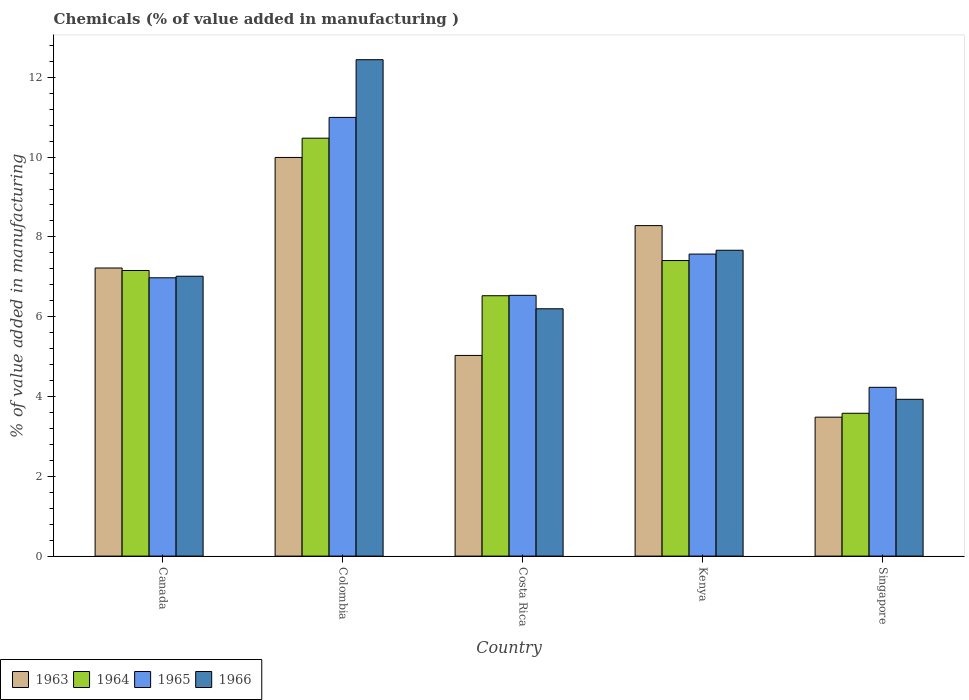Are the number of bars per tick equal to the number of legend labels?
Your answer should be compact. Yes. How many bars are there on the 1st tick from the left?
Give a very brief answer. 4. How many bars are there on the 2nd tick from the right?
Your response must be concise. 4. What is the label of the 5th group of bars from the left?
Offer a very short reply. Singapore. What is the value added in manufacturing chemicals in 1966 in Costa Rica?
Your response must be concise. 6.2. Across all countries, what is the maximum value added in manufacturing chemicals in 1964?
Make the answer very short. 10.47. Across all countries, what is the minimum value added in manufacturing chemicals in 1966?
Keep it short and to the point. 3.93. In which country was the value added in manufacturing chemicals in 1966 maximum?
Ensure brevity in your answer.  Colombia. In which country was the value added in manufacturing chemicals in 1963 minimum?
Your response must be concise. Singapore. What is the total value added in manufacturing chemicals in 1966 in the graph?
Make the answer very short. 37.25. What is the difference between the value added in manufacturing chemicals in 1964 in Costa Rica and that in Kenya?
Keep it short and to the point. -0.88. What is the difference between the value added in manufacturing chemicals in 1966 in Kenya and the value added in manufacturing chemicals in 1964 in Costa Rica?
Make the answer very short. 1.14. What is the average value added in manufacturing chemicals in 1964 per country?
Provide a short and direct response. 7.03. What is the difference between the value added in manufacturing chemicals of/in 1966 and value added in manufacturing chemicals of/in 1964 in Canada?
Offer a very short reply. -0.14. What is the ratio of the value added in manufacturing chemicals in 1966 in Costa Rica to that in Kenya?
Keep it short and to the point. 0.81. Is the value added in manufacturing chemicals in 1966 in Colombia less than that in Kenya?
Give a very brief answer. No. Is the difference between the value added in manufacturing chemicals in 1966 in Colombia and Kenya greater than the difference between the value added in manufacturing chemicals in 1964 in Colombia and Kenya?
Your answer should be very brief. Yes. What is the difference between the highest and the second highest value added in manufacturing chemicals in 1963?
Make the answer very short. -1.71. What is the difference between the highest and the lowest value added in manufacturing chemicals in 1965?
Offer a very short reply. 6.76. In how many countries, is the value added in manufacturing chemicals in 1964 greater than the average value added in manufacturing chemicals in 1964 taken over all countries?
Provide a succinct answer. 3. Is the sum of the value added in manufacturing chemicals in 1965 in Colombia and Singapore greater than the maximum value added in manufacturing chemicals in 1964 across all countries?
Give a very brief answer. Yes. Is it the case that in every country, the sum of the value added in manufacturing chemicals in 1966 and value added in manufacturing chemicals in 1963 is greater than the sum of value added in manufacturing chemicals in 1965 and value added in manufacturing chemicals in 1964?
Give a very brief answer. No. What does the 2nd bar from the left in Colombia represents?
Ensure brevity in your answer.  1964. Are the values on the major ticks of Y-axis written in scientific E-notation?
Provide a short and direct response. No. Does the graph contain any zero values?
Your answer should be compact. No. What is the title of the graph?
Your answer should be very brief. Chemicals (% of value added in manufacturing ). Does "2005" appear as one of the legend labels in the graph?
Provide a succinct answer. No. What is the label or title of the Y-axis?
Keep it short and to the point. % of value added in manufacturing. What is the % of value added in manufacturing of 1963 in Canada?
Your answer should be very brief. 7.22. What is the % of value added in manufacturing in 1964 in Canada?
Ensure brevity in your answer.  7.16. What is the % of value added in manufacturing in 1965 in Canada?
Your response must be concise. 6.98. What is the % of value added in manufacturing in 1966 in Canada?
Your response must be concise. 7.01. What is the % of value added in manufacturing of 1963 in Colombia?
Your response must be concise. 9.99. What is the % of value added in manufacturing of 1964 in Colombia?
Offer a very short reply. 10.47. What is the % of value added in manufacturing in 1965 in Colombia?
Your answer should be very brief. 10.99. What is the % of value added in manufacturing of 1966 in Colombia?
Your answer should be compact. 12.44. What is the % of value added in manufacturing in 1963 in Costa Rica?
Offer a terse response. 5.03. What is the % of value added in manufacturing in 1964 in Costa Rica?
Your answer should be compact. 6.53. What is the % of value added in manufacturing in 1965 in Costa Rica?
Your answer should be compact. 6.54. What is the % of value added in manufacturing in 1966 in Costa Rica?
Provide a short and direct response. 6.2. What is the % of value added in manufacturing in 1963 in Kenya?
Keep it short and to the point. 8.28. What is the % of value added in manufacturing in 1964 in Kenya?
Your answer should be very brief. 7.41. What is the % of value added in manufacturing in 1965 in Kenya?
Ensure brevity in your answer.  7.57. What is the % of value added in manufacturing in 1966 in Kenya?
Your answer should be very brief. 7.67. What is the % of value added in manufacturing of 1963 in Singapore?
Provide a short and direct response. 3.48. What is the % of value added in manufacturing of 1964 in Singapore?
Make the answer very short. 3.58. What is the % of value added in manufacturing of 1965 in Singapore?
Give a very brief answer. 4.23. What is the % of value added in manufacturing in 1966 in Singapore?
Ensure brevity in your answer.  3.93. Across all countries, what is the maximum % of value added in manufacturing of 1963?
Provide a short and direct response. 9.99. Across all countries, what is the maximum % of value added in manufacturing of 1964?
Make the answer very short. 10.47. Across all countries, what is the maximum % of value added in manufacturing of 1965?
Make the answer very short. 10.99. Across all countries, what is the maximum % of value added in manufacturing in 1966?
Offer a terse response. 12.44. Across all countries, what is the minimum % of value added in manufacturing in 1963?
Your answer should be compact. 3.48. Across all countries, what is the minimum % of value added in manufacturing of 1964?
Keep it short and to the point. 3.58. Across all countries, what is the minimum % of value added in manufacturing in 1965?
Provide a succinct answer. 4.23. Across all countries, what is the minimum % of value added in manufacturing in 1966?
Give a very brief answer. 3.93. What is the total % of value added in manufacturing of 1963 in the graph?
Make the answer very short. 34.01. What is the total % of value added in manufacturing of 1964 in the graph?
Provide a short and direct response. 35.15. What is the total % of value added in manufacturing of 1965 in the graph?
Ensure brevity in your answer.  36.31. What is the total % of value added in manufacturing in 1966 in the graph?
Offer a very short reply. 37.25. What is the difference between the % of value added in manufacturing of 1963 in Canada and that in Colombia?
Offer a terse response. -2.77. What is the difference between the % of value added in manufacturing of 1964 in Canada and that in Colombia?
Offer a terse response. -3.32. What is the difference between the % of value added in manufacturing in 1965 in Canada and that in Colombia?
Keep it short and to the point. -4.02. What is the difference between the % of value added in manufacturing in 1966 in Canada and that in Colombia?
Provide a short and direct response. -5.43. What is the difference between the % of value added in manufacturing of 1963 in Canada and that in Costa Rica?
Make the answer very short. 2.19. What is the difference between the % of value added in manufacturing of 1964 in Canada and that in Costa Rica?
Offer a terse response. 0.63. What is the difference between the % of value added in manufacturing in 1965 in Canada and that in Costa Rica?
Make the answer very short. 0.44. What is the difference between the % of value added in manufacturing in 1966 in Canada and that in Costa Rica?
Make the answer very short. 0.82. What is the difference between the % of value added in manufacturing in 1963 in Canada and that in Kenya?
Your answer should be very brief. -1.06. What is the difference between the % of value added in manufacturing of 1964 in Canada and that in Kenya?
Provide a succinct answer. -0.25. What is the difference between the % of value added in manufacturing in 1965 in Canada and that in Kenya?
Your answer should be very brief. -0.59. What is the difference between the % of value added in manufacturing in 1966 in Canada and that in Kenya?
Offer a terse response. -0.65. What is the difference between the % of value added in manufacturing of 1963 in Canada and that in Singapore?
Keep it short and to the point. 3.74. What is the difference between the % of value added in manufacturing of 1964 in Canada and that in Singapore?
Your answer should be compact. 3.58. What is the difference between the % of value added in manufacturing in 1965 in Canada and that in Singapore?
Provide a succinct answer. 2.75. What is the difference between the % of value added in manufacturing of 1966 in Canada and that in Singapore?
Offer a very short reply. 3.08. What is the difference between the % of value added in manufacturing in 1963 in Colombia and that in Costa Rica?
Your answer should be compact. 4.96. What is the difference between the % of value added in manufacturing of 1964 in Colombia and that in Costa Rica?
Provide a short and direct response. 3.95. What is the difference between the % of value added in manufacturing in 1965 in Colombia and that in Costa Rica?
Your response must be concise. 4.46. What is the difference between the % of value added in manufacturing in 1966 in Colombia and that in Costa Rica?
Your answer should be compact. 6.24. What is the difference between the % of value added in manufacturing in 1963 in Colombia and that in Kenya?
Your answer should be very brief. 1.71. What is the difference between the % of value added in manufacturing in 1964 in Colombia and that in Kenya?
Offer a terse response. 3.07. What is the difference between the % of value added in manufacturing of 1965 in Colombia and that in Kenya?
Keep it short and to the point. 3.43. What is the difference between the % of value added in manufacturing of 1966 in Colombia and that in Kenya?
Give a very brief answer. 4.78. What is the difference between the % of value added in manufacturing in 1963 in Colombia and that in Singapore?
Your response must be concise. 6.51. What is the difference between the % of value added in manufacturing in 1964 in Colombia and that in Singapore?
Make the answer very short. 6.89. What is the difference between the % of value added in manufacturing in 1965 in Colombia and that in Singapore?
Your answer should be very brief. 6.76. What is the difference between the % of value added in manufacturing in 1966 in Colombia and that in Singapore?
Offer a terse response. 8.51. What is the difference between the % of value added in manufacturing of 1963 in Costa Rica and that in Kenya?
Offer a very short reply. -3.25. What is the difference between the % of value added in manufacturing in 1964 in Costa Rica and that in Kenya?
Offer a terse response. -0.88. What is the difference between the % of value added in manufacturing of 1965 in Costa Rica and that in Kenya?
Offer a very short reply. -1.03. What is the difference between the % of value added in manufacturing of 1966 in Costa Rica and that in Kenya?
Provide a short and direct response. -1.47. What is the difference between the % of value added in manufacturing of 1963 in Costa Rica and that in Singapore?
Provide a short and direct response. 1.55. What is the difference between the % of value added in manufacturing in 1964 in Costa Rica and that in Singapore?
Provide a succinct answer. 2.95. What is the difference between the % of value added in manufacturing in 1965 in Costa Rica and that in Singapore?
Your answer should be very brief. 2.31. What is the difference between the % of value added in manufacturing of 1966 in Costa Rica and that in Singapore?
Provide a succinct answer. 2.27. What is the difference between the % of value added in manufacturing in 1963 in Kenya and that in Singapore?
Keep it short and to the point. 4.8. What is the difference between the % of value added in manufacturing of 1964 in Kenya and that in Singapore?
Provide a short and direct response. 3.83. What is the difference between the % of value added in manufacturing in 1965 in Kenya and that in Singapore?
Ensure brevity in your answer.  3.34. What is the difference between the % of value added in manufacturing in 1966 in Kenya and that in Singapore?
Offer a very short reply. 3.74. What is the difference between the % of value added in manufacturing in 1963 in Canada and the % of value added in manufacturing in 1964 in Colombia?
Ensure brevity in your answer.  -3.25. What is the difference between the % of value added in manufacturing in 1963 in Canada and the % of value added in manufacturing in 1965 in Colombia?
Provide a succinct answer. -3.77. What is the difference between the % of value added in manufacturing of 1963 in Canada and the % of value added in manufacturing of 1966 in Colombia?
Ensure brevity in your answer.  -5.22. What is the difference between the % of value added in manufacturing in 1964 in Canada and the % of value added in manufacturing in 1965 in Colombia?
Provide a succinct answer. -3.84. What is the difference between the % of value added in manufacturing in 1964 in Canada and the % of value added in manufacturing in 1966 in Colombia?
Provide a short and direct response. -5.28. What is the difference between the % of value added in manufacturing of 1965 in Canada and the % of value added in manufacturing of 1966 in Colombia?
Your answer should be very brief. -5.47. What is the difference between the % of value added in manufacturing in 1963 in Canada and the % of value added in manufacturing in 1964 in Costa Rica?
Your answer should be compact. 0.69. What is the difference between the % of value added in manufacturing of 1963 in Canada and the % of value added in manufacturing of 1965 in Costa Rica?
Your answer should be very brief. 0.68. What is the difference between the % of value added in manufacturing of 1963 in Canada and the % of value added in manufacturing of 1966 in Costa Rica?
Your answer should be compact. 1.02. What is the difference between the % of value added in manufacturing of 1964 in Canada and the % of value added in manufacturing of 1965 in Costa Rica?
Provide a succinct answer. 0.62. What is the difference between the % of value added in manufacturing in 1964 in Canada and the % of value added in manufacturing in 1966 in Costa Rica?
Give a very brief answer. 0.96. What is the difference between the % of value added in manufacturing of 1965 in Canada and the % of value added in manufacturing of 1966 in Costa Rica?
Your response must be concise. 0.78. What is the difference between the % of value added in manufacturing of 1963 in Canada and the % of value added in manufacturing of 1964 in Kenya?
Your answer should be compact. -0.19. What is the difference between the % of value added in manufacturing of 1963 in Canada and the % of value added in manufacturing of 1965 in Kenya?
Offer a very short reply. -0.35. What is the difference between the % of value added in manufacturing of 1963 in Canada and the % of value added in manufacturing of 1966 in Kenya?
Your response must be concise. -0.44. What is the difference between the % of value added in manufacturing of 1964 in Canada and the % of value added in manufacturing of 1965 in Kenya?
Offer a terse response. -0.41. What is the difference between the % of value added in manufacturing of 1964 in Canada and the % of value added in manufacturing of 1966 in Kenya?
Provide a succinct answer. -0.51. What is the difference between the % of value added in manufacturing in 1965 in Canada and the % of value added in manufacturing in 1966 in Kenya?
Make the answer very short. -0.69. What is the difference between the % of value added in manufacturing of 1963 in Canada and the % of value added in manufacturing of 1964 in Singapore?
Your answer should be very brief. 3.64. What is the difference between the % of value added in manufacturing in 1963 in Canada and the % of value added in manufacturing in 1965 in Singapore?
Offer a very short reply. 2.99. What is the difference between the % of value added in manufacturing in 1963 in Canada and the % of value added in manufacturing in 1966 in Singapore?
Provide a short and direct response. 3.29. What is the difference between the % of value added in manufacturing in 1964 in Canada and the % of value added in manufacturing in 1965 in Singapore?
Your response must be concise. 2.93. What is the difference between the % of value added in manufacturing in 1964 in Canada and the % of value added in manufacturing in 1966 in Singapore?
Ensure brevity in your answer.  3.23. What is the difference between the % of value added in manufacturing of 1965 in Canada and the % of value added in manufacturing of 1966 in Singapore?
Offer a terse response. 3.05. What is the difference between the % of value added in manufacturing of 1963 in Colombia and the % of value added in manufacturing of 1964 in Costa Rica?
Provide a short and direct response. 3.47. What is the difference between the % of value added in manufacturing in 1963 in Colombia and the % of value added in manufacturing in 1965 in Costa Rica?
Keep it short and to the point. 3.46. What is the difference between the % of value added in manufacturing of 1963 in Colombia and the % of value added in manufacturing of 1966 in Costa Rica?
Keep it short and to the point. 3.79. What is the difference between the % of value added in manufacturing of 1964 in Colombia and the % of value added in manufacturing of 1965 in Costa Rica?
Offer a very short reply. 3.94. What is the difference between the % of value added in manufacturing of 1964 in Colombia and the % of value added in manufacturing of 1966 in Costa Rica?
Offer a very short reply. 4.28. What is the difference between the % of value added in manufacturing of 1965 in Colombia and the % of value added in manufacturing of 1966 in Costa Rica?
Provide a succinct answer. 4.8. What is the difference between the % of value added in manufacturing in 1963 in Colombia and the % of value added in manufacturing in 1964 in Kenya?
Offer a very short reply. 2.58. What is the difference between the % of value added in manufacturing of 1963 in Colombia and the % of value added in manufacturing of 1965 in Kenya?
Your answer should be compact. 2.42. What is the difference between the % of value added in manufacturing in 1963 in Colombia and the % of value added in manufacturing in 1966 in Kenya?
Offer a very short reply. 2.33. What is the difference between the % of value added in manufacturing in 1964 in Colombia and the % of value added in manufacturing in 1965 in Kenya?
Make the answer very short. 2.9. What is the difference between the % of value added in manufacturing in 1964 in Colombia and the % of value added in manufacturing in 1966 in Kenya?
Your answer should be very brief. 2.81. What is the difference between the % of value added in manufacturing in 1965 in Colombia and the % of value added in manufacturing in 1966 in Kenya?
Provide a short and direct response. 3.33. What is the difference between the % of value added in manufacturing of 1963 in Colombia and the % of value added in manufacturing of 1964 in Singapore?
Your answer should be compact. 6.41. What is the difference between the % of value added in manufacturing of 1963 in Colombia and the % of value added in manufacturing of 1965 in Singapore?
Your response must be concise. 5.76. What is the difference between the % of value added in manufacturing in 1963 in Colombia and the % of value added in manufacturing in 1966 in Singapore?
Offer a very short reply. 6.06. What is the difference between the % of value added in manufacturing of 1964 in Colombia and the % of value added in manufacturing of 1965 in Singapore?
Provide a short and direct response. 6.24. What is the difference between the % of value added in manufacturing of 1964 in Colombia and the % of value added in manufacturing of 1966 in Singapore?
Make the answer very short. 6.54. What is the difference between the % of value added in manufacturing of 1965 in Colombia and the % of value added in manufacturing of 1966 in Singapore?
Your answer should be compact. 7.07. What is the difference between the % of value added in manufacturing of 1963 in Costa Rica and the % of value added in manufacturing of 1964 in Kenya?
Provide a succinct answer. -2.38. What is the difference between the % of value added in manufacturing in 1963 in Costa Rica and the % of value added in manufacturing in 1965 in Kenya?
Ensure brevity in your answer.  -2.54. What is the difference between the % of value added in manufacturing in 1963 in Costa Rica and the % of value added in manufacturing in 1966 in Kenya?
Your answer should be very brief. -2.64. What is the difference between the % of value added in manufacturing in 1964 in Costa Rica and the % of value added in manufacturing in 1965 in Kenya?
Your response must be concise. -1.04. What is the difference between the % of value added in manufacturing in 1964 in Costa Rica and the % of value added in manufacturing in 1966 in Kenya?
Give a very brief answer. -1.14. What is the difference between the % of value added in manufacturing in 1965 in Costa Rica and the % of value added in manufacturing in 1966 in Kenya?
Keep it short and to the point. -1.13. What is the difference between the % of value added in manufacturing of 1963 in Costa Rica and the % of value added in manufacturing of 1964 in Singapore?
Provide a short and direct response. 1.45. What is the difference between the % of value added in manufacturing in 1963 in Costa Rica and the % of value added in manufacturing in 1965 in Singapore?
Ensure brevity in your answer.  0.8. What is the difference between the % of value added in manufacturing in 1963 in Costa Rica and the % of value added in manufacturing in 1966 in Singapore?
Keep it short and to the point. 1.1. What is the difference between the % of value added in manufacturing in 1964 in Costa Rica and the % of value added in manufacturing in 1965 in Singapore?
Ensure brevity in your answer.  2.3. What is the difference between the % of value added in manufacturing in 1964 in Costa Rica and the % of value added in manufacturing in 1966 in Singapore?
Your answer should be very brief. 2.6. What is the difference between the % of value added in manufacturing of 1965 in Costa Rica and the % of value added in manufacturing of 1966 in Singapore?
Your response must be concise. 2.61. What is the difference between the % of value added in manufacturing in 1963 in Kenya and the % of value added in manufacturing in 1964 in Singapore?
Your answer should be very brief. 4.7. What is the difference between the % of value added in manufacturing of 1963 in Kenya and the % of value added in manufacturing of 1965 in Singapore?
Offer a very short reply. 4.05. What is the difference between the % of value added in manufacturing in 1963 in Kenya and the % of value added in manufacturing in 1966 in Singapore?
Offer a very short reply. 4.35. What is the difference between the % of value added in manufacturing in 1964 in Kenya and the % of value added in manufacturing in 1965 in Singapore?
Give a very brief answer. 3.18. What is the difference between the % of value added in manufacturing in 1964 in Kenya and the % of value added in manufacturing in 1966 in Singapore?
Keep it short and to the point. 3.48. What is the difference between the % of value added in manufacturing of 1965 in Kenya and the % of value added in manufacturing of 1966 in Singapore?
Keep it short and to the point. 3.64. What is the average % of value added in manufacturing in 1963 per country?
Ensure brevity in your answer.  6.8. What is the average % of value added in manufacturing of 1964 per country?
Offer a terse response. 7.03. What is the average % of value added in manufacturing in 1965 per country?
Ensure brevity in your answer.  7.26. What is the average % of value added in manufacturing of 1966 per country?
Offer a very short reply. 7.45. What is the difference between the % of value added in manufacturing in 1963 and % of value added in manufacturing in 1964 in Canada?
Provide a short and direct response. 0.06. What is the difference between the % of value added in manufacturing in 1963 and % of value added in manufacturing in 1965 in Canada?
Your response must be concise. 0.25. What is the difference between the % of value added in manufacturing in 1963 and % of value added in manufacturing in 1966 in Canada?
Offer a very short reply. 0.21. What is the difference between the % of value added in manufacturing in 1964 and % of value added in manufacturing in 1965 in Canada?
Offer a terse response. 0.18. What is the difference between the % of value added in manufacturing in 1964 and % of value added in manufacturing in 1966 in Canada?
Provide a short and direct response. 0.14. What is the difference between the % of value added in manufacturing of 1965 and % of value added in manufacturing of 1966 in Canada?
Your answer should be very brief. -0.04. What is the difference between the % of value added in manufacturing of 1963 and % of value added in manufacturing of 1964 in Colombia?
Provide a short and direct response. -0.48. What is the difference between the % of value added in manufacturing of 1963 and % of value added in manufacturing of 1965 in Colombia?
Provide a short and direct response. -1. What is the difference between the % of value added in manufacturing in 1963 and % of value added in manufacturing in 1966 in Colombia?
Keep it short and to the point. -2.45. What is the difference between the % of value added in manufacturing in 1964 and % of value added in manufacturing in 1965 in Colombia?
Offer a terse response. -0.52. What is the difference between the % of value added in manufacturing of 1964 and % of value added in manufacturing of 1966 in Colombia?
Your answer should be very brief. -1.97. What is the difference between the % of value added in manufacturing of 1965 and % of value added in manufacturing of 1966 in Colombia?
Provide a succinct answer. -1.45. What is the difference between the % of value added in manufacturing of 1963 and % of value added in manufacturing of 1964 in Costa Rica?
Your answer should be very brief. -1.5. What is the difference between the % of value added in manufacturing of 1963 and % of value added in manufacturing of 1965 in Costa Rica?
Your answer should be compact. -1.51. What is the difference between the % of value added in manufacturing in 1963 and % of value added in manufacturing in 1966 in Costa Rica?
Provide a short and direct response. -1.17. What is the difference between the % of value added in manufacturing of 1964 and % of value added in manufacturing of 1965 in Costa Rica?
Ensure brevity in your answer.  -0.01. What is the difference between the % of value added in manufacturing of 1964 and % of value added in manufacturing of 1966 in Costa Rica?
Provide a short and direct response. 0.33. What is the difference between the % of value added in manufacturing of 1965 and % of value added in manufacturing of 1966 in Costa Rica?
Make the answer very short. 0.34. What is the difference between the % of value added in manufacturing of 1963 and % of value added in manufacturing of 1964 in Kenya?
Provide a short and direct response. 0.87. What is the difference between the % of value added in manufacturing of 1963 and % of value added in manufacturing of 1965 in Kenya?
Provide a succinct answer. 0.71. What is the difference between the % of value added in manufacturing in 1963 and % of value added in manufacturing in 1966 in Kenya?
Offer a very short reply. 0.62. What is the difference between the % of value added in manufacturing of 1964 and % of value added in manufacturing of 1965 in Kenya?
Your answer should be compact. -0.16. What is the difference between the % of value added in manufacturing in 1964 and % of value added in manufacturing in 1966 in Kenya?
Your response must be concise. -0.26. What is the difference between the % of value added in manufacturing in 1965 and % of value added in manufacturing in 1966 in Kenya?
Keep it short and to the point. -0.1. What is the difference between the % of value added in manufacturing of 1963 and % of value added in manufacturing of 1964 in Singapore?
Give a very brief answer. -0.1. What is the difference between the % of value added in manufacturing of 1963 and % of value added in manufacturing of 1965 in Singapore?
Provide a short and direct response. -0.75. What is the difference between the % of value added in manufacturing of 1963 and % of value added in manufacturing of 1966 in Singapore?
Your answer should be compact. -0.45. What is the difference between the % of value added in manufacturing in 1964 and % of value added in manufacturing in 1965 in Singapore?
Keep it short and to the point. -0.65. What is the difference between the % of value added in manufacturing in 1964 and % of value added in manufacturing in 1966 in Singapore?
Provide a short and direct response. -0.35. What is the difference between the % of value added in manufacturing of 1965 and % of value added in manufacturing of 1966 in Singapore?
Provide a succinct answer. 0.3. What is the ratio of the % of value added in manufacturing in 1963 in Canada to that in Colombia?
Provide a short and direct response. 0.72. What is the ratio of the % of value added in manufacturing in 1964 in Canada to that in Colombia?
Your answer should be very brief. 0.68. What is the ratio of the % of value added in manufacturing in 1965 in Canada to that in Colombia?
Your answer should be very brief. 0.63. What is the ratio of the % of value added in manufacturing of 1966 in Canada to that in Colombia?
Make the answer very short. 0.56. What is the ratio of the % of value added in manufacturing of 1963 in Canada to that in Costa Rica?
Your answer should be compact. 1.44. What is the ratio of the % of value added in manufacturing of 1964 in Canada to that in Costa Rica?
Make the answer very short. 1.1. What is the ratio of the % of value added in manufacturing in 1965 in Canada to that in Costa Rica?
Your response must be concise. 1.07. What is the ratio of the % of value added in manufacturing in 1966 in Canada to that in Costa Rica?
Offer a terse response. 1.13. What is the ratio of the % of value added in manufacturing of 1963 in Canada to that in Kenya?
Provide a succinct answer. 0.87. What is the ratio of the % of value added in manufacturing in 1964 in Canada to that in Kenya?
Ensure brevity in your answer.  0.97. What is the ratio of the % of value added in manufacturing in 1965 in Canada to that in Kenya?
Provide a succinct answer. 0.92. What is the ratio of the % of value added in manufacturing of 1966 in Canada to that in Kenya?
Give a very brief answer. 0.92. What is the ratio of the % of value added in manufacturing of 1963 in Canada to that in Singapore?
Give a very brief answer. 2.07. What is the ratio of the % of value added in manufacturing in 1964 in Canada to that in Singapore?
Provide a succinct answer. 2. What is the ratio of the % of value added in manufacturing in 1965 in Canada to that in Singapore?
Offer a very short reply. 1.65. What is the ratio of the % of value added in manufacturing of 1966 in Canada to that in Singapore?
Make the answer very short. 1.78. What is the ratio of the % of value added in manufacturing of 1963 in Colombia to that in Costa Rica?
Keep it short and to the point. 1.99. What is the ratio of the % of value added in manufacturing of 1964 in Colombia to that in Costa Rica?
Offer a terse response. 1.61. What is the ratio of the % of value added in manufacturing of 1965 in Colombia to that in Costa Rica?
Provide a short and direct response. 1.68. What is the ratio of the % of value added in manufacturing of 1966 in Colombia to that in Costa Rica?
Offer a very short reply. 2.01. What is the ratio of the % of value added in manufacturing in 1963 in Colombia to that in Kenya?
Your answer should be compact. 1.21. What is the ratio of the % of value added in manufacturing in 1964 in Colombia to that in Kenya?
Ensure brevity in your answer.  1.41. What is the ratio of the % of value added in manufacturing of 1965 in Colombia to that in Kenya?
Make the answer very short. 1.45. What is the ratio of the % of value added in manufacturing in 1966 in Colombia to that in Kenya?
Your answer should be very brief. 1.62. What is the ratio of the % of value added in manufacturing in 1963 in Colombia to that in Singapore?
Your answer should be very brief. 2.87. What is the ratio of the % of value added in manufacturing in 1964 in Colombia to that in Singapore?
Your answer should be very brief. 2.93. What is the ratio of the % of value added in manufacturing in 1965 in Colombia to that in Singapore?
Keep it short and to the point. 2.6. What is the ratio of the % of value added in manufacturing of 1966 in Colombia to that in Singapore?
Give a very brief answer. 3.17. What is the ratio of the % of value added in manufacturing in 1963 in Costa Rica to that in Kenya?
Ensure brevity in your answer.  0.61. What is the ratio of the % of value added in manufacturing of 1964 in Costa Rica to that in Kenya?
Ensure brevity in your answer.  0.88. What is the ratio of the % of value added in manufacturing of 1965 in Costa Rica to that in Kenya?
Your answer should be very brief. 0.86. What is the ratio of the % of value added in manufacturing in 1966 in Costa Rica to that in Kenya?
Provide a short and direct response. 0.81. What is the ratio of the % of value added in manufacturing of 1963 in Costa Rica to that in Singapore?
Make the answer very short. 1.44. What is the ratio of the % of value added in manufacturing of 1964 in Costa Rica to that in Singapore?
Make the answer very short. 1.82. What is the ratio of the % of value added in manufacturing in 1965 in Costa Rica to that in Singapore?
Provide a short and direct response. 1.55. What is the ratio of the % of value added in manufacturing of 1966 in Costa Rica to that in Singapore?
Ensure brevity in your answer.  1.58. What is the ratio of the % of value added in manufacturing in 1963 in Kenya to that in Singapore?
Keep it short and to the point. 2.38. What is the ratio of the % of value added in manufacturing in 1964 in Kenya to that in Singapore?
Give a very brief answer. 2.07. What is the ratio of the % of value added in manufacturing of 1965 in Kenya to that in Singapore?
Give a very brief answer. 1.79. What is the ratio of the % of value added in manufacturing in 1966 in Kenya to that in Singapore?
Make the answer very short. 1.95. What is the difference between the highest and the second highest % of value added in manufacturing of 1963?
Your response must be concise. 1.71. What is the difference between the highest and the second highest % of value added in manufacturing of 1964?
Provide a succinct answer. 3.07. What is the difference between the highest and the second highest % of value added in manufacturing of 1965?
Provide a short and direct response. 3.43. What is the difference between the highest and the second highest % of value added in manufacturing in 1966?
Your answer should be compact. 4.78. What is the difference between the highest and the lowest % of value added in manufacturing in 1963?
Your answer should be very brief. 6.51. What is the difference between the highest and the lowest % of value added in manufacturing of 1964?
Provide a succinct answer. 6.89. What is the difference between the highest and the lowest % of value added in manufacturing of 1965?
Give a very brief answer. 6.76. What is the difference between the highest and the lowest % of value added in manufacturing of 1966?
Your response must be concise. 8.51. 